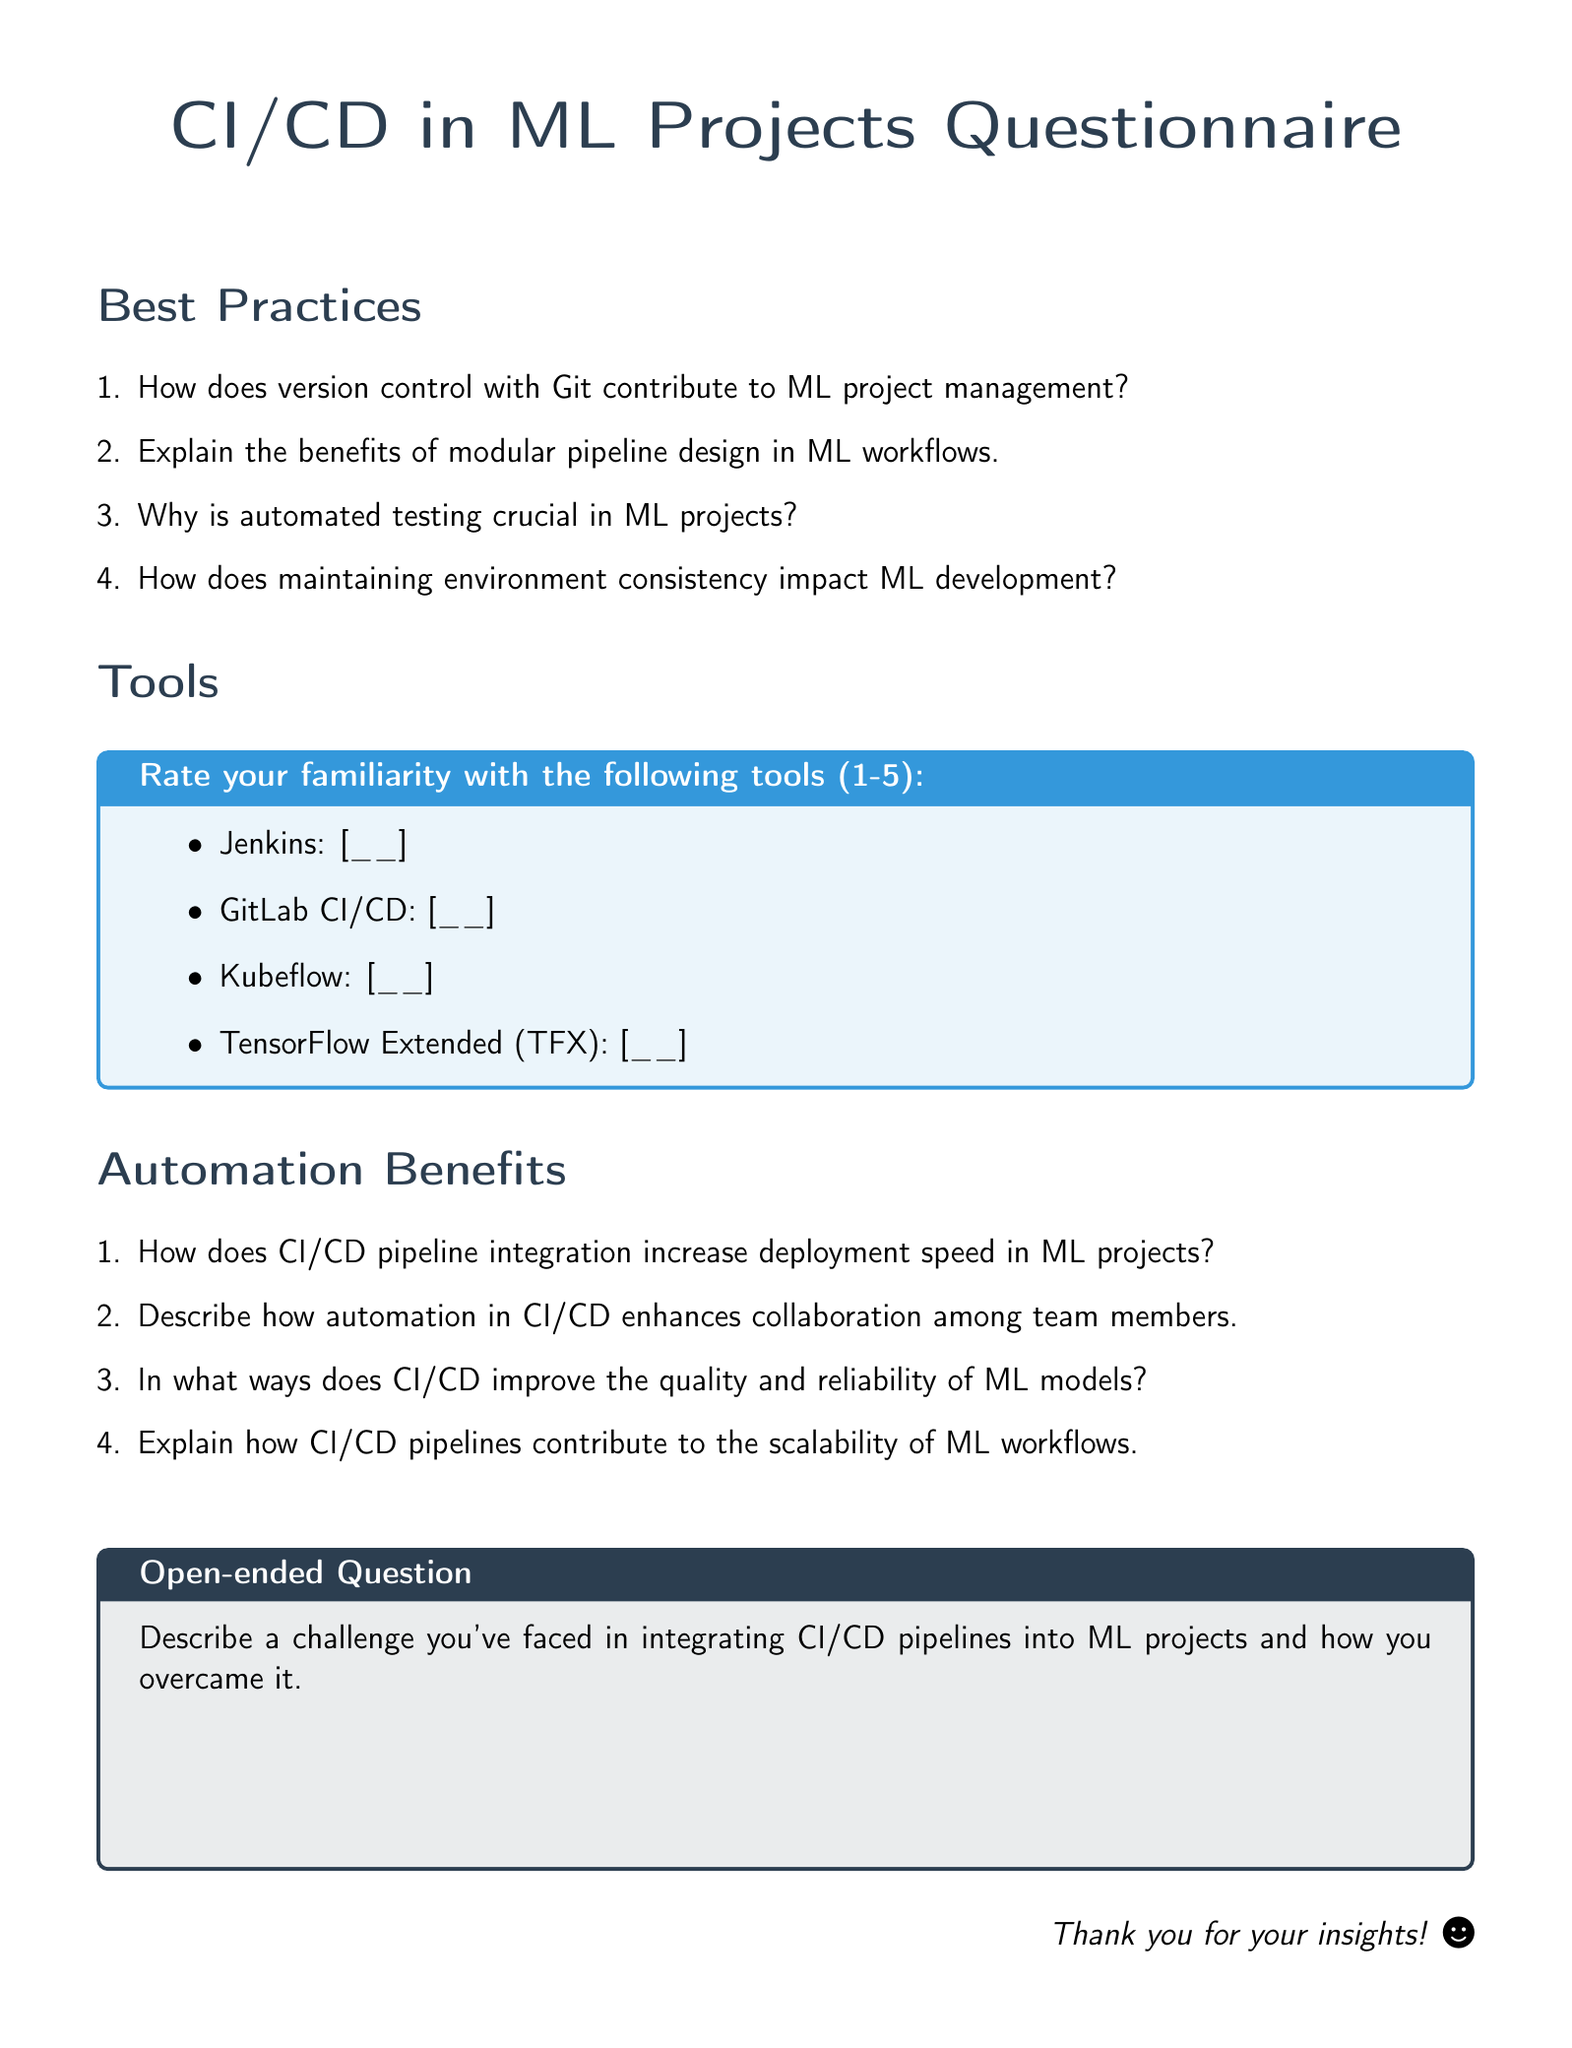What is the main topic of the document? The document presents a questionnaire focusing on the integration of CI/CD pipelines in machine learning projects, covering best practices, tools, and automation benefits.
Answer: CI/CD in ML Projects How many sections are present in the document? The document has three main sections: Best Practices, Tools, and Automation Benefits.
Answer: 3 What tool is mentioned first in the Tools section? The first tool listed in the Tools section is Jenkins.
Answer: Jenkins What does CI/CD pipeline integration increase in ML projects? The document states that CI/CD pipeline integration increases deployment speed in ML projects.
Answer: Deployment speed What is the format used for rating familiarity with tools? The familiarity with the tools is rated on a scale of 1 to 5.
Answer: 1-5 What type of question is provided at the end of the document? The last question in the document is open-ended, allowing for a detailed personal response regarding challenges faced in CI/CD integration.
Answer: Open-ended Question What color is used for the box in the Tools section? The color used for the box in the Tools section is a shade of blue (second color).
Answer: Blue How many questions are in the Best Practices section? There are four questions listed in the Best Practices section.
Answer: 4 Which tool is ranked second in the Tools section? The second tool listed in the Tools section is GitLab CI/CD.
Answer: GitLab CI/CD 